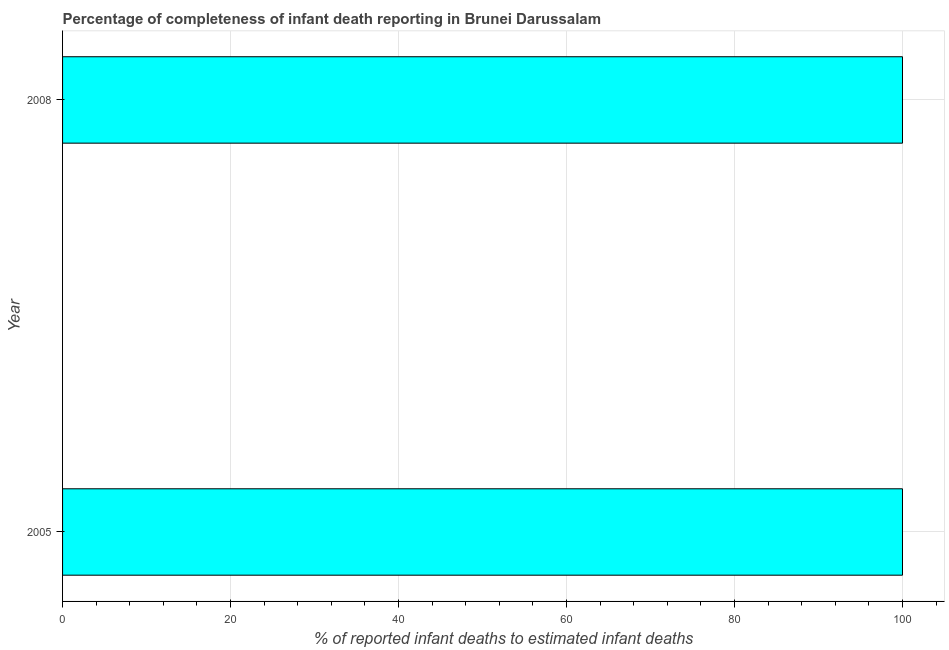Does the graph contain grids?
Your answer should be compact. Yes. What is the title of the graph?
Your answer should be very brief. Percentage of completeness of infant death reporting in Brunei Darussalam. What is the label or title of the X-axis?
Your answer should be very brief. % of reported infant deaths to estimated infant deaths. What is the completeness of infant death reporting in 2008?
Offer a terse response. 100. Across all years, what is the minimum completeness of infant death reporting?
Provide a short and direct response. 100. What is the sum of the completeness of infant death reporting?
Keep it short and to the point. 200. What is the difference between the completeness of infant death reporting in 2005 and 2008?
Offer a terse response. 0. What is the median completeness of infant death reporting?
Your answer should be compact. 100. What is the ratio of the completeness of infant death reporting in 2005 to that in 2008?
Provide a succinct answer. 1. Is the completeness of infant death reporting in 2005 less than that in 2008?
Keep it short and to the point. No. In how many years, is the completeness of infant death reporting greater than the average completeness of infant death reporting taken over all years?
Your response must be concise. 0. How many bars are there?
Your answer should be very brief. 2. Are all the bars in the graph horizontal?
Your response must be concise. Yes. How many years are there in the graph?
Your answer should be compact. 2. 